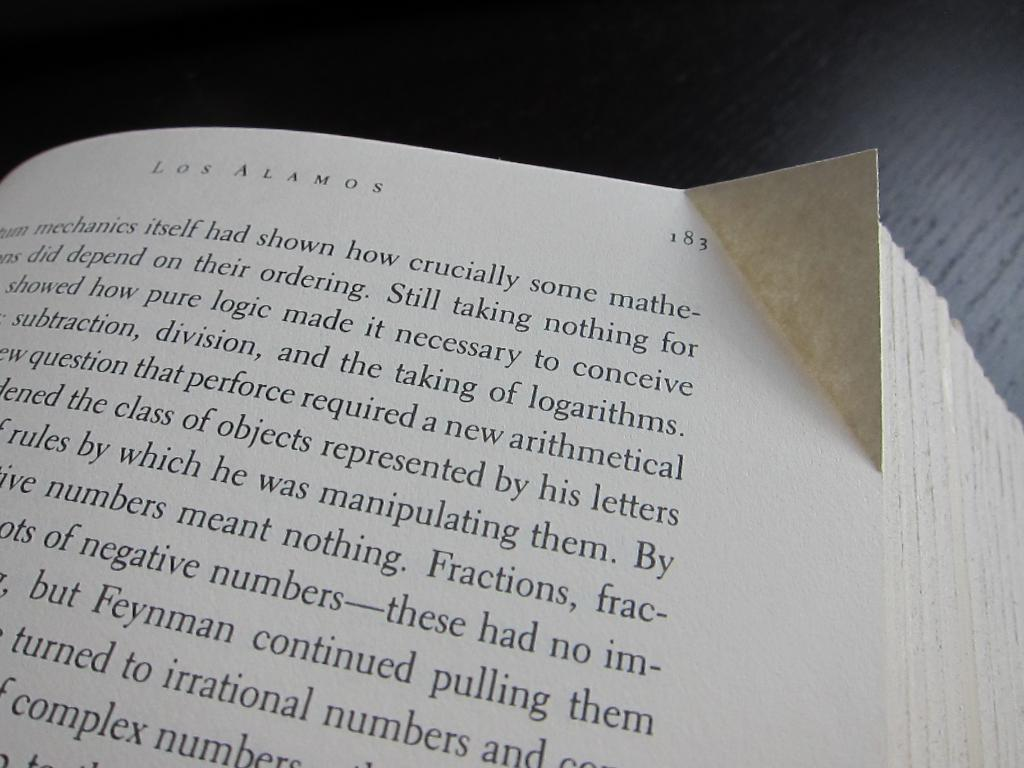<image>
Write a terse but informative summary of the picture. A close up of page 183 from the book Los Alamos. 